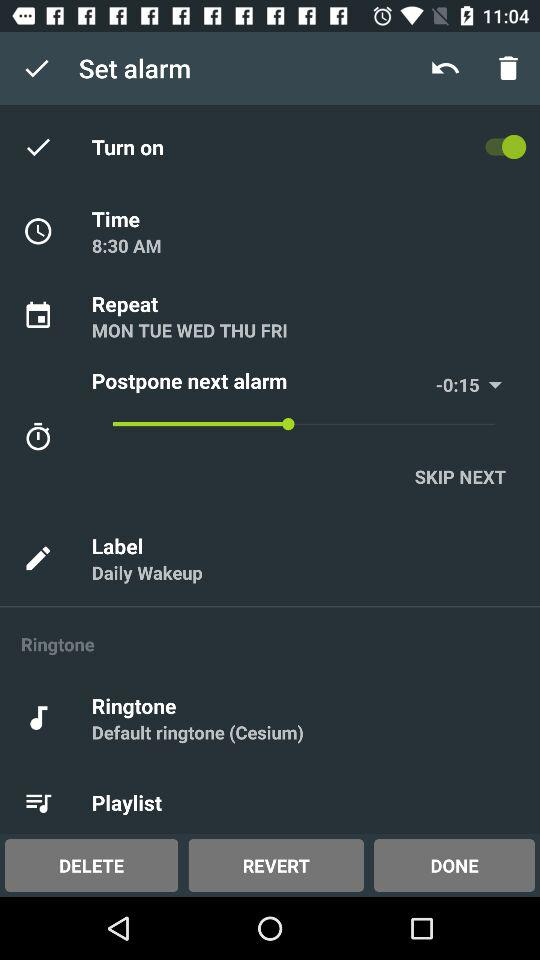What is the label for the set alarm? The label is "Daily Wakeup". 